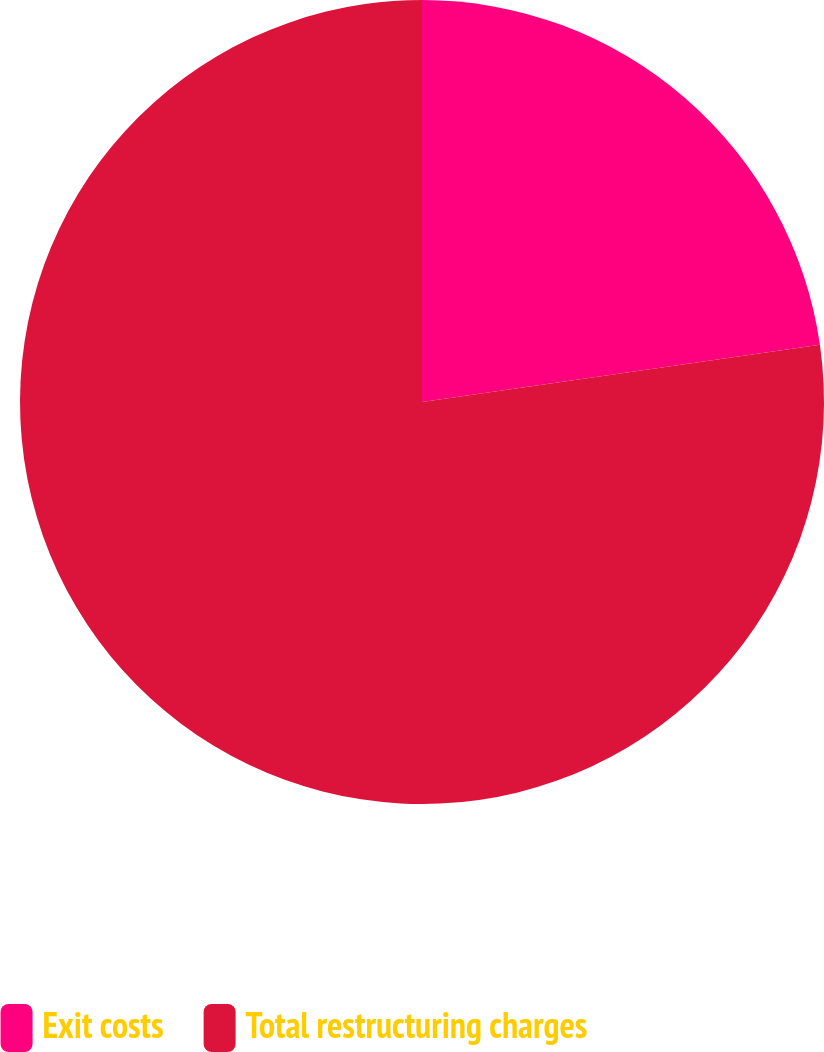Convert chart. <chart><loc_0><loc_0><loc_500><loc_500><pie_chart><fcel>Exit costs<fcel>Total restructuring charges<nl><fcel>22.73%<fcel>77.27%<nl></chart> 